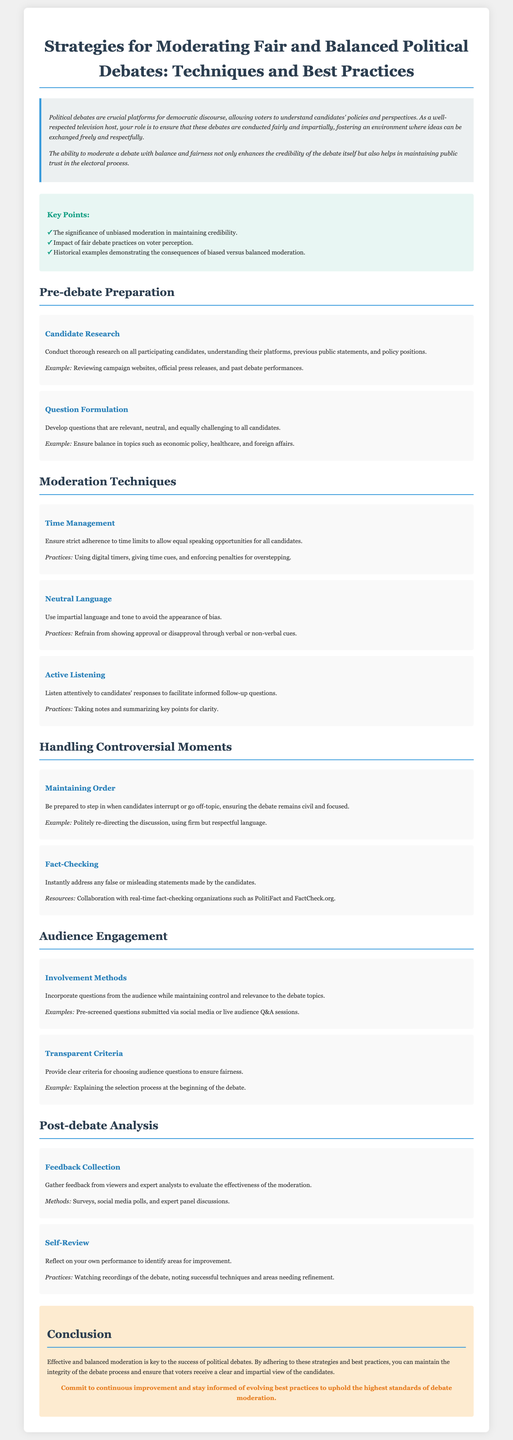What is the title of the document? The title provides the main focus of the whitepaper, which is "Strategies for Moderating Fair and Balanced Political Debates".
Answer: Strategies for Moderating Fair and Balanced Political Debates Who is the intended audience for this document? The introduction describes the role of the host, indicating that it is intended for television hosts and moderators.
Answer: Television hosts What are key points mentioned in the document? The key points highlight significant issues that affect political debates, including unbiased moderation and voter perception.
Answer: Unbiased moderation in maintaining credibility, Impact of fair debate practices on voter perception, Historical examples demonstrating consequences What is one technique for time management in debates? The moderation techniques section suggests a practical approach to managing speaking time among candidates.
Answer: Using digital timers What is one method suggested for audience involvement? The document lists involvement methods as a way to enhance engagement during the debate.
Answer: Pre-screened questions Which organization is mentioned as a resource for fact-checking? Real-time fact-checking is emphasized as a part of debate moderation practices.
Answer: PolitiFact What should be provided at the beginning of the debate regarding audience questions? The document advises transparency to ensure fairness during the audience engagement segment.
Answer: Clear criteria for choosing audience questions What should a moderator do to maintain order during the debate? Handling controversial moments requires moderation techniques to ensure civility.
Answer: Politely redirecting the discussion How can a moderator collect feedback after the debate? Feedback collection after debates could involve various methods to evaluate moderation effectiveness.
Answer: Surveys 